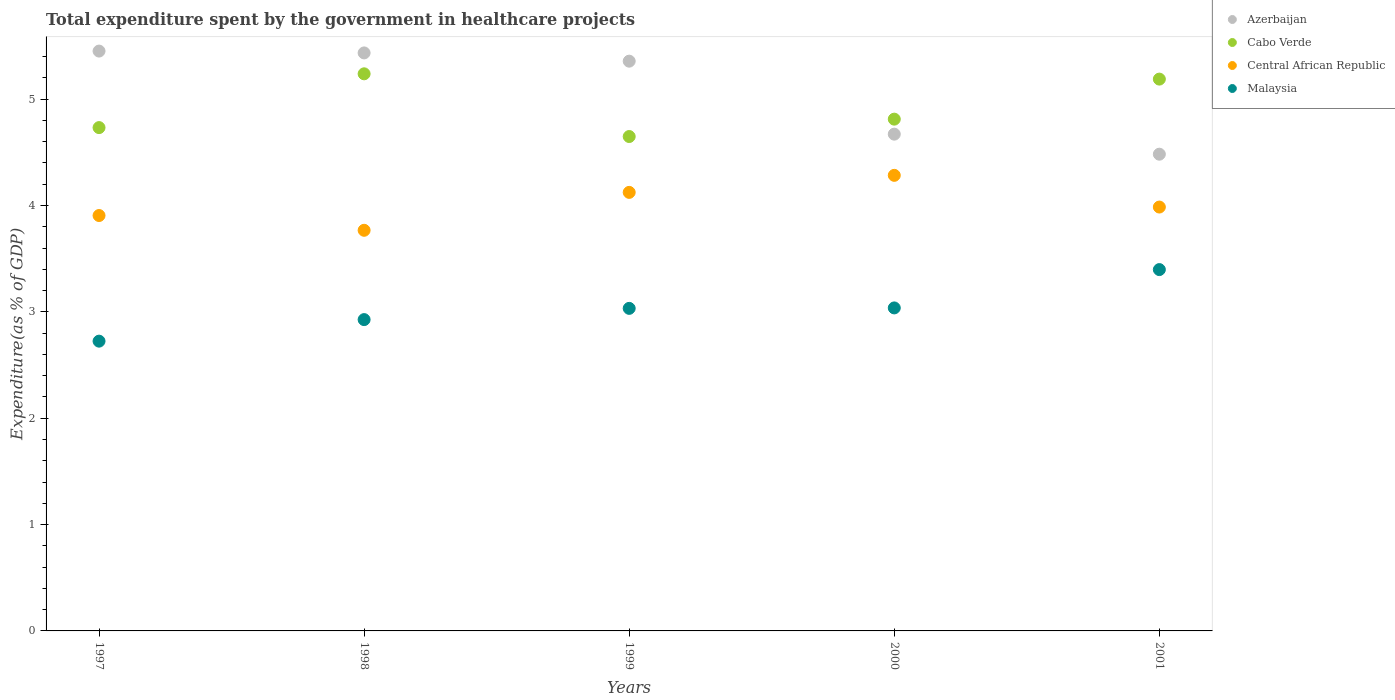How many different coloured dotlines are there?
Keep it short and to the point. 4. Is the number of dotlines equal to the number of legend labels?
Offer a terse response. Yes. What is the total expenditure spent by the government in healthcare projects in Central African Republic in 1997?
Offer a terse response. 3.91. Across all years, what is the maximum total expenditure spent by the government in healthcare projects in Cabo Verde?
Give a very brief answer. 5.24. Across all years, what is the minimum total expenditure spent by the government in healthcare projects in Azerbaijan?
Provide a short and direct response. 4.48. What is the total total expenditure spent by the government in healthcare projects in Azerbaijan in the graph?
Offer a very short reply. 25.4. What is the difference between the total expenditure spent by the government in healthcare projects in Malaysia in 1998 and that in 1999?
Your answer should be very brief. -0.11. What is the difference between the total expenditure spent by the government in healthcare projects in Azerbaijan in 1997 and the total expenditure spent by the government in healthcare projects in Central African Republic in 1999?
Make the answer very short. 1.33. What is the average total expenditure spent by the government in healthcare projects in Malaysia per year?
Ensure brevity in your answer.  3.02. In the year 2000, what is the difference between the total expenditure spent by the government in healthcare projects in Cabo Verde and total expenditure spent by the government in healthcare projects in Central African Republic?
Your response must be concise. 0.53. What is the ratio of the total expenditure spent by the government in healthcare projects in Azerbaijan in 1998 to that in 1999?
Your response must be concise. 1.01. What is the difference between the highest and the second highest total expenditure spent by the government in healthcare projects in Central African Republic?
Your response must be concise. 0.16. What is the difference between the highest and the lowest total expenditure spent by the government in healthcare projects in Central African Republic?
Ensure brevity in your answer.  0.52. Is the sum of the total expenditure spent by the government in healthcare projects in Cabo Verde in 1998 and 1999 greater than the maximum total expenditure spent by the government in healthcare projects in Azerbaijan across all years?
Make the answer very short. Yes. Is it the case that in every year, the sum of the total expenditure spent by the government in healthcare projects in Malaysia and total expenditure spent by the government in healthcare projects in Central African Republic  is greater than the sum of total expenditure spent by the government in healthcare projects in Azerbaijan and total expenditure spent by the government in healthcare projects in Cabo Verde?
Give a very brief answer. No. Is it the case that in every year, the sum of the total expenditure spent by the government in healthcare projects in Central African Republic and total expenditure spent by the government in healthcare projects in Azerbaijan  is greater than the total expenditure spent by the government in healthcare projects in Cabo Verde?
Keep it short and to the point. Yes. Is the total expenditure spent by the government in healthcare projects in Cabo Verde strictly greater than the total expenditure spent by the government in healthcare projects in Malaysia over the years?
Your answer should be compact. Yes. Is the total expenditure spent by the government in healthcare projects in Malaysia strictly less than the total expenditure spent by the government in healthcare projects in Central African Republic over the years?
Your answer should be very brief. Yes. Are the values on the major ticks of Y-axis written in scientific E-notation?
Your answer should be compact. No. Does the graph contain any zero values?
Give a very brief answer. No. How many legend labels are there?
Your answer should be very brief. 4. How are the legend labels stacked?
Provide a succinct answer. Vertical. What is the title of the graph?
Provide a short and direct response. Total expenditure spent by the government in healthcare projects. Does "Togo" appear as one of the legend labels in the graph?
Your response must be concise. No. What is the label or title of the X-axis?
Provide a short and direct response. Years. What is the label or title of the Y-axis?
Your answer should be compact. Expenditure(as % of GDP). What is the Expenditure(as % of GDP) of Azerbaijan in 1997?
Your answer should be compact. 5.45. What is the Expenditure(as % of GDP) of Cabo Verde in 1997?
Give a very brief answer. 4.73. What is the Expenditure(as % of GDP) in Central African Republic in 1997?
Make the answer very short. 3.91. What is the Expenditure(as % of GDP) in Malaysia in 1997?
Give a very brief answer. 2.72. What is the Expenditure(as % of GDP) in Azerbaijan in 1998?
Make the answer very short. 5.43. What is the Expenditure(as % of GDP) of Cabo Verde in 1998?
Give a very brief answer. 5.24. What is the Expenditure(as % of GDP) of Central African Republic in 1998?
Provide a short and direct response. 3.77. What is the Expenditure(as % of GDP) in Malaysia in 1998?
Make the answer very short. 2.93. What is the Expenditure(as % of GDP) in Azerbaijan in 1999?
Offer a terse response. 5.36. What is the Expenditure(as % of GDP) of Cabo Verde in 1999?
Your response must be concise. 4.65. What is the Expenditure(as % of GDP) of Central African Republic in 1999?
Make the answer very short. 4.12. What is the Expenditure(as % of GDP) in Malaysia in 1999?
Your response must be concise. 3.03. What is the Expenditure(as % of GDP) of Azerbaijan in 2000?
Ensure brevity in your answer.  4.67. What is the Expenditure(as % of GDP) of Cabo Verde in 2000?
Provide a succinct answer. 4.81. What is the Expenditure(as % of GDP) of Central African Republic in 2000?
Offer a terse response. 4.28. What is the Expenditure(as % of GDP) in Malaysia in 2000?
Make the answer very short. 3.04. What is the Expenditure(as % of GDP) in Azerbaijan in 2001?
Ensure brevity in your answer.  4.48. What is the Expenditure(as % of GDP) of Cabo Verde in 2001?
Provide a short and direct response. 5.19. What is the Expenditure(as % of GDP) of Central African Republic in 2001?
Ensure brevity in your answer.  3.99. What is the Expenditure(as % of GDP) of Malaysia in 2001?
Offer a terse response. 3.4. Across all years, what is the maximum Expenditure(as % of GDP) of Azerbaijan?
Make the answer very short. 5.45. Across all years, what is the maximum Expenditure(as % of GDP) in Cabo Verde?
Provide a succinct answer. 5.24. Across all years, what is the maximum Expenditure(as % of GDP) in Central African Republic?
Provide a succinct answer. 4.28. Across all years, what is the maximum Expenditure(as % of GDP) in Malaysia?
Provide a succinct answer. 3.4. Across all years, what is the minimum Expenditure(as % of GDP) of Azerbaijan?
Offer a very short reply. 4.48. Across all years, what is the minimum Expenditure(as % of GDP) in Cabo Verde?
Give a very brief answer. 4.65. Across all years, what is the minimum Expenditure(as % of GDP) in Central African Republic?
Keep it short and to the point. 3.77. Across all years, what is the minimum Expenditure(as % of GDP) of Malaysia?
Keep it short and to the point. 2.72. What is the total Expenditure(as % of GDP) of Azerbaijan in the graph?
Provide a short and direct response. 25.4. What is the total Expenditure(as % of GDP) of Cabo Verde in the graph?
Your answer should be compact. 24.62. What is the total Expenditure(as % of GDP) of Central African Republic in the graph?
Provide a short and direct response. 20.07. What is the total Expenditure(as % of GDP) of Malaysia in the graph?
Your response must be concise. 15.12. What is the difference between the Expenditure(as % of GDP) in Azerbaijan in 1997 and that in 1998?
Provide a succinct answer. 0.02. What is the difference between the Expenditure(as % of GDP) of Cabo Verde in 1997 and that in 1998?
Ensure brevity in your answer.  -0.51. What is the difference between the Expenditure(as % of GDP) of Central African Republic in 1997 and that in 1998?
Provide a short and direct response. 0.14. What is the difference between the Expenditure(as % of GDP) in Malaysia in 1997 and that in 1998?
Your answer should be very brief. -0.2. What is the difference between the Expenditure(as % of GDP) of Azerbaijan in 1997 and that in 1999?
Offer a terse response. 0.09. What is the difference between the Expenditure(as % of GDP) of Cabo Verde in 1997 and that in 1999?
Provide a short and direct response. 0.08. What is the difference between the Expenditure(as % of GDP) of Central African Republic in 1997 and that in 1999?
Offer a very short reply. -0.22. What is the difference between the Expenditure(as % of GDP) in Malaysia in 1997 and that in 1999?
Provide a succinct answer. -0.31. What is the difference between the Expenditure(as % of GDP) of Azerbaijan in 1997 and that in 2000?
Offer a terse response. 0.78. What is the difference between the Expenditure(as % of GDP) in Cabo Verde in 1997 and that in 2000?
Provide a short and direct response. -0.08. What is the difference between the Expenditure(as % of GDP) of Central African Republic in 1997 and that in 2000?
Provide a succinct answer. -0.38. What is the difference between the Expenditure(as % of GDP) of Malaysia in 1997 and that in 2000?
Offer a terse response. -0.31. What is the difference between the Expenditure(as % of GDP) in Azerbaijan in 1997 and that in 2001?
Provide a short and direct response. 0.97. What is the difference between the Expenditure(as % of GDP) in Cabo Verde in 1997 and that in 2001?
Your answer should be very brief. -0.46. What is the difference between the Expenditure(as % of GDP) of Central African Republic in 1997 and that in 2001?
Your response must be concise. -0.08. What is the difference between the Expenditure(as % of GDP) in Malaysia in 1997 and that in 2001?
Offer a terse response. -0.67. What is the difference between the Expenditure(as % of GDP) in Azerbaijan in 1998 and that in 1999?
Offer a very short reply. 0.08. What is the difference between the Expenditure(as % of GDP) in Cabo Verde in 1998 and that in 1999?
Give a very brief answer. 0.59. What is the difference between the Expenditure(as % of GDP) of Central African Republic in 1998 and that in 1999?
Give a very brief answer. -0.36. What is the difference between the Expenditure(as % of GDP) of Malaysia in 1998 and that in 1999?
Ensure brevity in your answer.  -0.11. What is the difference between the Expenditure(as % of GDP) of Azerbaijan in 1998 and that in 2000?
Your answer should be very brief. 0.76. What is the difference between the Expenditure(as % of GDP) of Cabo Verde in 1998 and that in 2000?
Offer a terse response. 0.43. What is the difference between the Expenditure(as % of GDP) in Central African Republic in 1998 and that in 2000?
Provide a short and direct response. -0.52. What is the difference between the Expenditure(as % of GDP) of Malaysia in 1998 and that in 2000?
Give a very brief answer. -0.11. What is the difference between the Expenditure(as % of GDP) of Azerbaijan in 1998 and that in 2001?
Offer a very short reply. 0.95. What is the difference between the Expenditure(as % of GDP) of Cabo Verde in 1998 and that in 2001?
Your answer should be very brief. 0.05. What is the difference between the Expenditure(as % of GDP) of Central African Republic in 1998 and that in 2001?
Your answer should be very brief. -0.22. What is the difference between the Expenditure(as % of GDP) of Malaysia in 1998 and that in 2001?
Your answer should be very brief. -0.47. What is the difference between the Expenditure(as % of GDP) of Azerbaijan in 1999 and that in 2000?
Keep it short and to the point. 0.69. What is the difference between the Expenditure(as % of GDP) in Cabo Verde in 1999 and that in 2000?
Ensure brevity in your answer.  -0.16. What is the difference between the Expenditure(as % of GDP) in Central African Republic in 1999 and that in 2000?
Provide a succinct answer. -0.16. What is the difference between the Expenditure(as % of GDP) of Malaysia in 1999 and that in 2000?
Your response must be concise. -0. What is the difference between the Expenditure(as % of GDP) in Azerbaijan in 1999 and that in 2001?
Provide a short and direct response. 0.87. What is the difference between the Expenditure(as % of GDP) in Cabo Verde in 1999 and that in 2001?
Keep it short and to the point. -0.54. What is the difference between the Expenditure(as % of GDP) of Central African Republic in 1999 and that in 2001?
Give a very brief answer. 0.14. What is the difference between the Expenditure(as % of GDP) in Malaysia in 1999 and that in 2001?
Ensure brevity in your answer.  -0.36. What is the difference between the Expenditure(as % of GDP) in Azerbaijan in 2000 and that in 2001?
Give a very brief answer. 0.19. What is the difference between the Expenditure(as % of GDP) in Cabo Verde in 2000 and that in 2001?
Offer a terse response. -0.38. What is the difference between the Expenditure(as % of GDP) of Central African Republic in 2000 and that in 2001?
Keep it short and to the point. 0.3. What is the difference between the Expenditure(as % of GDP) in Malaysia in 2000 and that in 2001?
Give a very brief answer. -0.36. What is the difference between the Expenditure(as % of GDP) of Azerbaijan in 1997 and the Expenditure(as % of GDP) of Cabo Verde in 1998?
Provide a succinct answer. 0.21. What is the difference between the Expenditure(as % of GDP) of Azerbaijan in 1997 and the Expenditure(as % of GDP) of Central African Republic in 1998?
Your response must be concise. 1.69. What is the difference between the Expenditure(as % of GDP) of Azerbaijan in 1997 and the Expenditure(as % of GDP) of Malaysia in 1998?
Provide a succinct answer. 2.52. What is the difference between the Expenditure(as % of GDP) in Cabo Verde in 1997 and the Expenditure(as % of GDP) in Central African Republic in 1998?
Your answer should be very brief. 0.97. What is the difference between the Expenditure(as % of GDP) in Cabo Verde in 1997 and the Expenditure(as % of GDP) in Malaysia in 1998?
Provide a short and direct response. 1.81. What is the difference between the Expenditure(as % of GDP) in Central African Republic in 1997 and the Expenditure(as % of GDP) in Malaysia in 1998?
Make the answer very short. 0.98. What is the difference between the Expenditure(as % of GDP) of Azerbaijan in 1997 and the Expenditure(as % of GDP) of Cabo Verde in 1999?
Keep it short and to the point. 0.8. What is the difference between the Expenditure(as % of GDP) in Azerbaijan in 1997 and the Expenditure(as % of GDP) in Central African Republic in 1999?
Your answer should be compact. 1.33. What is the difference between the Expenditure(as % of GDP) in Azerbaijan in 1997 and the Expenditure(as % of GDP) in Malaysia in 1999?
Offer a terse response. 2.42. What is the difference between the Expenditure(as % of GDP) of Cabo Verde in 1997 and the Expenditure(as % of GDP) of Central African Republic in 1999?
Offer a terse response. 0.61. What is the difference between the Expenditure(as % of GDP) in Cabo Verde in 1997 and the Expenditure(as % of GDP) in Malaysia in 1999?
Give a very brief answer. 1.7. What is the difference between the Expenditure(as % of GDP) of Central African Republic in 1997 and the Expenditure(as % of GDP) of Malaysia in 1999?
Provide a succinct answer. 0.87. What is the difference between the Expenditure(as % of GDP) of Azerbaijan in 1997 and the Expenditure(as % of GDP) of Cabo Verde in 2000?
Make the answer very short. 0.64. What is the difference between the Expenditure(as % of GDP) in Azerbaijan in 1997 and the Expenditure(as % of GDP) in Central African Republic in 2000?
Give a very brief answer. 1.17. What is the difference between the Expenditure(as % of GDP) in Azerbaijan in 1997 and the Expenditure(as % of GDP) in Malaysia in 2000?
Offer a terse response. 2.42. What is the difference between the Expenditure(as % of GDP) in Cabo Verde in 1997 and the Expenditure(as % of GDP) in Central African Republic in 2000?
Offer a very short reply. 0.45. What is the difference between the Expenditure(as % of GDP) in Cabo Verde in 1997 and the Expenditure(as % of GDP) in Malaysia in 2000?
Provide a short and direct response. 1.7. What is the difference between the Expenditure(as % of GDP) of Central African Republic in 1997 and the Expenditure(as % of GDP) of Malaysia in 2000?
Offer a terse response. 0.87. What is the difference between the Expenditure(as % of GDP) of Azerbaijan in 1997 and the Expenditure(as % of GDP) of Cabo Verde in 2001?
Offer a very short reply. 0.26. What is the difference between the Expenditure(as % of GDP) of Azerbaijan in 1997 and the Expenditure(as % of GDP) of Central African Republic in 2001?
Provide a succinct answer. 1.47. What is the difference between the Expenditure(as % of GDP) in Azerbaijan in 1997 and the Expenditure(as % of GDP) in Malaysia in 2001?
Make the answer very short. 2.05. What is the difference between the Expenditure(as % of GDP) of Cabo Verde in 1997 and the Expenditure(as % of GDP) of Central African Republic in 2001?
Ensure brevity in your answer.  0.75. What is the difference between the Expenditure(as % of GDP) in Cabo Verde in 1997 and the Expenditure(as % of GDP) in Malaysia in 2001?
Your answer should be very brief. 1.33. What is the difference between the Expenditure(as % of GDP) of Central African Republic in 1997 and the Expenditure(as % of GDP) of Malaysia in 2001?
Your answer should be compact. 0.51. What is the difference between the Expenditure(as % of GDP) of Azerbaijan in 1998 and the Expenditure(as % of GDP) of Cabo Verde in 1999?
Offer a very short reply. 0.79. What is the difference between the Expenditure(as % of GDP) in Azerbaijan in 1998 and the Expenditure(as % of GDP) in Central African Republic in 1999?
Provide a succinct answer. 1.31. What is the difference between the Expenditure(as % of GDP) of Azerbaijan in 1998 and the Expenditure(as % of GDP) of Malaysia in 1999?
Offer a very short reply. 2.4. What is the difference between the Expenditure(as % of GDP) of Cabo Verde in 1998 and the Expenditure(as % of GDP) of Central African Republic in 1999?
Provide a short and direct response. 1.11. What is the difference between the Expenditure(as % of GDP) of Cabo Verde in 1998 and the Expenditure(as % of GDP) of Malaysia in 1999?
Your answer should be compact. 2.21. What is the difference between the Expenditure(as % of GDP) of Central African Republic in 1998 and the Expenditure(as % of GDP) of Malaysia in 1999?
Offer a terse response. 0.73. What is the difference between the Expenditure(as % of GDP) in Azerbaijan in 1998 and the Expenditure(as % of GDP) in Cabo Verde in 2000?
Make the answer very short. 0.62. What is the difference between the Expenditure(as % of GDP) in Azerbaijan in 1998 and the Expenditure(as % of GDP) in Central African Republic in 2000?
Your answer should be compact. 1.15. What is the difference between the Expenditure(as % of GDP) in Azerbaijan in 1998 and the Expenditure(as % of GDP) in Malaysia in 2000?
Your response must be concise. 2.4. What is the difference between the Expenditure(as % of GDP) in Cabo Verde in 1998 and the Expenditure(as % of GDP) in Central African Republic in 2000?
Ensure brevity in your answer.  0.95. What is the difference between the Expenditure(as % of GDP) in Cabo Verde in 1998 and the Expenditure(as % of GDP) in Malaysia in 2000?
Offer a very short reply. 2.2. What is the difference between the Expenditure(as % of GDP) in Central African Republic in 1998 and the Expenditure(as % of GDP) in Malaysia in 2000?
Provide a short and direct response. 0.73. What is the difference between the Expenditure(as % of GDP) in Azerbaijan in 1998 and the Expenditure(as % of GDP) in Cabo Verde in 2001?
Give a very brief answer. 0.25. What is the difference between the Expenditure(as % of GDP) of Azerbaijan in 1998 and the Expenditure(as % of GDP) of Central African Republic in 2001?
Offer a terse response. 1.45. What is the difference between the Expenditure(as % of GDP) of Azerbaijan in 1998 and the Expenditure(as % of GDP) of Malaysia in 2001?
Offer a terse response. 2.04. What is the difference between the Expenditure(as % of GDP) of Cabo Verde in 1998 and the Expenditure(as % of GDP) of Central African Republic in 2001?
Your answer should be compact. 1.25. What is the difference between the Expenditure(as % of GDP) in Cabo Verde in 1998 and the Expenditure(as % of GDP) in Malaysia in 2001?
Keep it short and to the point. 1.84. What is the difference between the Expenditure(as % of GDP) in Central African Republic in 1998 and the Expenditure(as % of GDP) in Malaysia in 2001?
Ensure brevity in your answer.  0.37. What is the difference between the Expenditure(as % of GDP) in Azerbaijan in 1999 and the Expenditure(as % of GDP) in Cabo Verde in 2000?
Your response must be concise. 0.55. What is the difference between the Expenditure(as % of GDP) in Azerbaijan in 1999 and the Expenditure(as % of GDP) in Central African Republic in 2000?
Your response must be concise. 1.07. What is the difference between the Expenditure(as % of GDP) of Azerbaijan in 1999 and the Expenditure(as % of GDP) of Malaysia in 2000?
Your response must be concise. 2.32. What is the difference between the Expenditure(as % of GDP) in Cabo Verde in 1999 and the Expenditure(as % of GDP) in Central African Republic in 2000?
Provide a short and direct response. 0.36. What is the difference between the Expenditure(as % of GDP) in Cabo Verde in 1999 and the Expenditure(as % of GDP) in Malaysia in 2000?
Make the answer very short. 1.61. What is the difference between the Expenditure(as % of GDP) of Central African Republic in 1999 and the Expenditure(as % of GDP) of Malaysia in 2000?
Ensure brevity in your answer.  1.09. What is the difference between the Expenditure(as % of GDP) in Azerbaijan in 1999 and the Expenditure(as % of GDP) in Cabo Verde in 2001?
Give a very brief answer. 0.17. What is the difference between the Expenditure(as % of GDP) in Azerbaijan in 1999 and the Expenditure(as % of GDP) in Central African Republic in 2001?
Make the answer very short. 1.37. What is the difference between the Expenditure(as % of GDP) of Azerbaijan in 1999 and the Expenditure(as % of GDP) of Malaysia in 2001?
Your answer should be compact. 1.96. What is the difference between the Expenditure(as % of GDP) in Cabo Verde in 1999 and the Expenditure(as % of GDP) in Central African Republic in 2001?
Keep it short and to the point. 0.66. What is the difference between the Expenditure(as % of GDP) in Cabo Verde in 1999 and the Expenditure(as % of GDP) in Malaysia in 2001?
Keep it short and to the point. 1.25. What is the difference between the Expenditure(as % of GDP) in Central African Republic in 1999 and the Expenditure(as % of GDP) in Malaysia in 2001?
Your answer should be very brief. 0.73. What is the difference between the Expenditure(as % of GDP) in Azerbaijan in 2000 and the Expenditure(as % of GDP) in Cabo Verde in 2001?
Your response must be concise. -0.52. What is the difference between the Expenditure(as % of GDP) in Azerbaijan in 2000 and the Expenditure(as % of GDP) in Central African Republic in 2001?
Your response must be concise. 0.69. What is the difference between the Expenditure(as % of GDP) in Azerbaijan in 2000 and the Expenditure(as % of GDP) in Malaysia in 2001?
Your answer should be very brief. 1.27. What is the difference between the Expenditure(as % of GDP) of Cabo Verde in 2000 and the Expenditure(as % of GDP) of Central African Republic in 2001?
Your answer should be compact. 0.83. What is the difference between the Expenditure(as % of GDP) in Cabo Verde in 2000 and the Expenditure(as % of GDP) in Malaysia in 2001?
Provide a short and direct response. 1.41. What is the difference between the Expenditure(as % of GDP) in Central African Republic in 2000 and the Expenditure(as % of GDP) in Malaysia in 2001?
Your answer should be compact. 0.89. What is the average Expenditure(as % of GDP) of Azerbaijan per year?
Give a very brief answer. 5.08. What is the average Expenditure(as % of GDP) in Cabo Verde per year?
Ensure brevity in your answer.  4.92. What is the average Expenditure(as % of GDP) of Central African Republic per year?
Your response must be concise. 4.01. What is the average Expenditure(as % of GDP) of Malaysia per year?
Your answer should be very brief. 3.02. In the year 1997, what is the difference between the Expenditure(as % of GDP) in Azerbaijan and Expenditure(as % of GDP) in Cabo Verde?
Provide a short and direct response. 0.72. In the year 1997, what is the difference between the Expenditure(as % of GDP) in Azerbaijan and Expenditure(as % of GDP) in Central African Republic?
Make the answer very short. 1.55. In the year 1997, what is the difference between the Expenditure(as % of GDP) in Azerbaijan and Expenditure(as % of GDP) in Malaysia?
Provide a succinct answer. 2.73. In the year 1997, what is the difference between the Expenditure(as % of GDP) in Cabo Verde and Expenditure(as % of GDP) in Central African Republic?
Your answer should be compact. 0.83. In the year 1997, what is the difference between the Expenditure(as % of GDP) in Cabo Verde and Expenditure(as % of GDP) in Malaysia?
Your answer should be compact. 2.01. In the year 1997, what is the difference between the Expenditure(as % of GDP) in Central African Republic and Expenditure(as % of GDP) in Malaysia?
Give a very brief answer. 1.18. In the year 1998, what is the difference between the Expenditure(as % of GDP) of Azerbaijan and Expenditure(as % of GDP) of Cabo Verde?
Provide a short and direct response. 0.2. In the year 1998, what is the difference between the Expenditure(as % of GDP) in Azerbaijan and Expenditure(as % of GDP) in Central African Republic?
Your answer should be compact. 1.67. In the year 1998, what is the difference between the Expenditure(as % of GDP) in Azerbaijan and Expenditure(as % of GDP) in Malaysia?
Your answer should be very brief. 2.51. In the year 1998, what is the difference between the Expenditure(as % of GDP) of Cabo Verde and Expenditure(as % of GDP) of Central African Republic?
Provide a short and direct response. 1.47. In the year 1998, what is the difference between the Expenditure(as % of GDP) of Cabo Verde and Expenditure(as % of GDP) of Malaysia?
Make the answer very short. 2.31. In the year 1998, what is the difference between the Expenditure(as % of GDP) of Central African Republic and Expenditure(as % of GDP) of Malaysia?
Make the answer very short. 0.84. In the year 1999, what is the difference between the Expenditure(as % of GDP) in Azerbaijan and Expenditure(as % of GDP) in Cabo Verde?
Make the answer very short. 0.71. In the year 1999, what is the difference between the Expenditure(as % of GDP) in Azerbaijan and Expenditure(as % of GDP) in Central African Republic?
Offer a terse response. 1.23. In the year 1999, what is the difference between the Expenditure(as % of GDP) of Azerbaijan and Expenditure(as % of GDP) of Malaysia?
Your answer should be very brief. 2.32. In the year 1999, what is the difference between the Expenditure(as % of GDP) of Cabo Verde and Expenditure(as % of GDP) of Central African Republic?
Your answer should be compact. 0.53. In the year 1999, what is the difference between the Expenditure(as % of GDP) of Cabo Verde and Expenditure(as % of GDP) of Malaysia?
Offer a very short reply. 1.62. In the year 1999, what is the difference between the Expenditure(as % of GDP) in Central African Republic and Expenditure(as % of GDP) in Malaysia?
Make the answer very short. 1.09. In the year 2000, what is the difference between the Expenditure(as % of GDP) of Azerbaijan and Expenditure(as % of GDP) of Cabo Verde?
Offer a terse response. -0.14. In the year 2000, what is the difference between the Expenditure(as % of GDP) in Azerbaijan and Expenditure(as % of GDP) in Central African Republic?
Give a very brief answer. 0.39. In the year 2000, what is the difference between the Expenditure(as % of GDP) of Azerbaijan and Expenditure(as % of GDP) of Malaysia?
Your response must be concise. 1.63. In the year 2000, what is the difference between the Expenditure(as % of GDP) of Cabo Verde and Expenditure(as % of GDP) of Central African Republic?
Make the answer very short. 0.53. In the year 2000, what is the difference between the Expenditure(as % of GDP) of Cabo Verde and Expenditure(as % of GDP) of Malaysia?
Your response must be concise. 1.77. In the year 2000, what is the difference between the Expenditure(as % of GDP) in Central African Republic and Expenditure(as % of GDP) in Malaysia?
Your answer should be very brief. 1.25. In the year 2001, what is the difference between the Expenditure(as % of GDP) in Azerbaijan and Expenditure(as % of GDP) in Cabo Verde?
Your answer should be compact. -0.71. In the year 2001, what is the difference between the Expenditure(as % of GDP) of Azerbaijan and Expenditure(as % of GDP) of Central African Republic?
Make the answer very short. 0.5. In the year 2001, what is the difference between the Expenditure(as % of GDP) in Azerbaijan and Expenditure(as % of GDP) in Malaysia?
Your answer should be compact. 1.08. In the year 2001, what is the difference between the Expenditure(as % of GDP) of Cabo Verde and Expenditure(as % of GDP) of Central African Republic?
Your response must be concise. 1.2. In the year 2001, what is the difference between the Expenditure(as % of GDP) of Cabo Verde and Expenditure(as % of GDP) of Malaysia?
Your answer should be compact. 1.79. In the year 2001, what is the difference between the Expenditure(as % of GDP) of Central African Republic and Expenditure(as % of GDP) of Malaysia?
Offer a very short reply. 0.59. What is the ratio of the Expenditure(as % of GDP) in Cabo Verde in 1997 to that in 1998?
Keep it short and to the point. 0.9. What is the ratio of the Expenditure(as % of GDP) of Central African Republic in 1997 to that in 1998?
Make the answer very short. 1.04. What is the ratio of the Expenditure(as % of GDP) of Malaysia in 1997 to that in 1998?
Give a very brief answer. 0.93. What is the ratio of the Expenditure(as % of GDP) in Azerbaijan in 1997 to that in 1999?
Your answer should be very brief. 1.02. What is the ratio of the Expenditure(as % of GDP) in Cabo Verde in 1997 to that in 1999?
Your answer should be very brief. 1.02. What is the ratio of the Expenditure(as % of GDP) in Central African Republic in 1997 to that in 1999?
Provide a succinct answer. 0.95. What is the ratio of the Expenditure(as % of GDP) of Malaysia in 1997 to that in 1999?
Provide a short and direct response. 0.9. What is the ratio of the Expenditure(as % of GDP) of Azerbaijan in 1997 to that in 2000?
Give a very brief answer. 1.17. What is the ratio of the Expenditure(as % of GDP) in Cabo Verde in 1997 to that in 2000?
Your answer should be compact. 0.98. What is the ratio of the Expenditure(as % of GDP) in Central African Republic in 1997 to that in 2000?
Your response must be concise. 0.91. What is the ratio of the Expenditure(as % of GDP) of Malaysia in 1997 to that in 2000?
Your response must be concise. 0.9. What is the ratio of the Expenditure(as % of GDP) of Azerbaijan in 1997 to that in 2001?
Make the answer very short. 1.22. What is the ratio of the Expenditure(as % of GDP) of Cabo Verde in 1997 to that in 2001?
Your answer should be compact. 0.91. What is the ratio of the Expenditure(as % of GDP) of Malaysia in 1997 to that in 2001?
Keep it short and to the point. 0.8. What is the ratio of the Expenditure(as % of GDP) in Azerbaijan in 1998 to that in 1999?
Offer a terse response. 1.01. What is the ratio of the Expenditure(as % of GDP) in Cabo Verde in 1998 to that in 1999?
Provide a succinct answer. 1.13. What is the ratio of the Expenditure(as % of GDP) of Central African Republic in 1998 to that in 1999?
Make the answer very short. 0.91. What is the ratio of the Expenditure(as % of GDP) in Malaysia in 1998 to that in 1999?
Your answer should be very brief. 0.97. What is the ratio of the Expenditure(as % of GDP) in Azerbaijan in 1998 to that in 2000?
Offer a very short reply. 1.16. What is the ratio of the Expenditure(as % of GDP) in Cabo Verde in 1998 to that in 2000?
Your answer should be very brief. 1.09. What is the ratio of the Expenditure(as % of GDP) of Central African Republic in 1998 to that in 2000?
Your answer should be very brief. 0.88. What is the ratio of the Expenditure(as % of GDP) of Malaysia in 1998 to that in 2000?
Give a very brief answer. 0.96. What is the ratio of the Expenditure(as % of GDP) in Azerbaijan in 1998 to that in 2001?
Provide a short and direct response. 1.21. What is the ratio of the Expenditure(as % of GDP) of Cabo Verde in 1998 to that in 2001?
Keep it short and to the point. 1.01. What is the ratio of the Expenditure(as % of GDP) of Central African Republic in 1998 to that in 2001?
Provide a succinct answer. 0.95. What is the ratio of the Expenditure(as % of GDP) in Malaysia in 1998 to that in 2001?
Your response must be concise. 0.86. What is the ratio of the Expenditure(as % of GDP) of Azerbaijan in 1999 to that in 2000?
Your answer should be very brief. 1.15. What is the ratio of the Expenditure(as % of GDP) in Central African Republic in 1999 to that in 2000?
Provide a succinct answer. 0.96. What is the ratio of the Expenditure(as % of GDP) in Malaysia in 1999 to that in 2000?
Your answer should be compact. 1. What is the ratio of the Expenditure(as % of GDP) in Azerbaijan in 1999 to that in 2001?
Your response must be concise. 1.2. What is the ratio of the Expenditure(as % of GDP) of Cabo Verde in 1999 to that in 2001?
Keep it short and to the point. 0.9. What is the ratio of the Expenditure(as % of GDP) of Central African Republic in 1999 to that in 2001?
Offer a terse response. 1.03. What is the ratio of the Expenditure(as % of GDP) of Malaysia in 1999 to that in 2001?
Provide a succinct answer. 0.89. What is the ratio of the Expenditure(as % of GDP) of Azerbaijan in 2000 to that in 2001?
Your response must be concise. 1.04. What is the ratio of the Expenditure(as % of GDP) of Cabo Verde in 2000 to that in 2001?
Provide a succinct answer. 0.93. What is the ratio of the Expenditure(as % of GDP) in Central African Republic in 2000 to that in 2001?
Make the answer very short. 1.07. What is the ratio of the Expenditure(as % of GDP) of Malaysia in 2000 to that in 2001?
Provide a succinct answer. 0.89. What is the difference between the highest and the second highest Expenditure(as % of GDP) in Azerbaijan?
Provide a short and direct response. 0.02. What is the difference between the highest and the second highest Expenditure(as % of GDP) in Cabo Verde?
Your answer should be compact. 0.05. What is the difference between the highest and the second highest Expenditure(as % of GDP) of Central African Republic?
Your answer should be compact. 0.16. What is the difference between the highest and the second highest Expenditure(as % of GDP) of Malaysia?
Make the answer very short. 0.36. What is the difference between the highest and the lowest Expenditure(as % of GDP) of Azerbaijan?
Keep it short and to the point. 0.97. What is the difference between the highest and the lowest Expenditure(as % of GDP) in Cabo Verde?
Your answer should be very brief. 0.59. What is the difference between the highest and the lowest Expenditure(as % of GDP) in Central African Republic?
Provide a short and direct response. 0.52. What is the difference between the highest and the lowest Expenditure(as % of GDP) of Malaysia?
Provide a short and direct response. 0.67. 